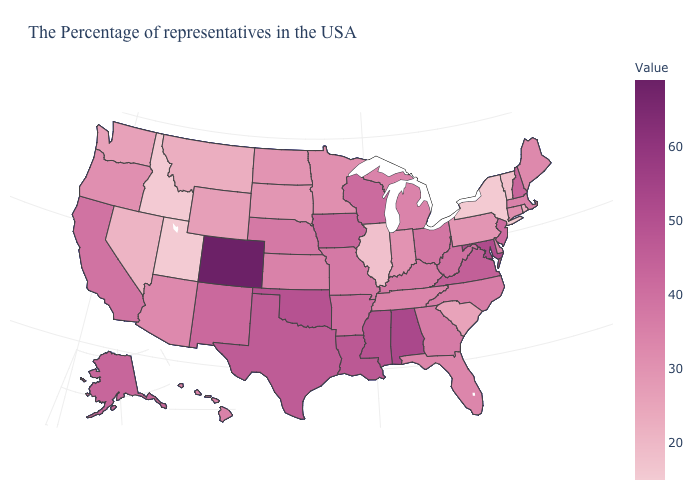Does Utah have the lowest value in the USA?
Write a very short answer. Yes. Does South Carolina have the lowest value in the South?
Short answer required. Yes. Does Alabama have a higher value than Colorado?
Short answer required. No. 